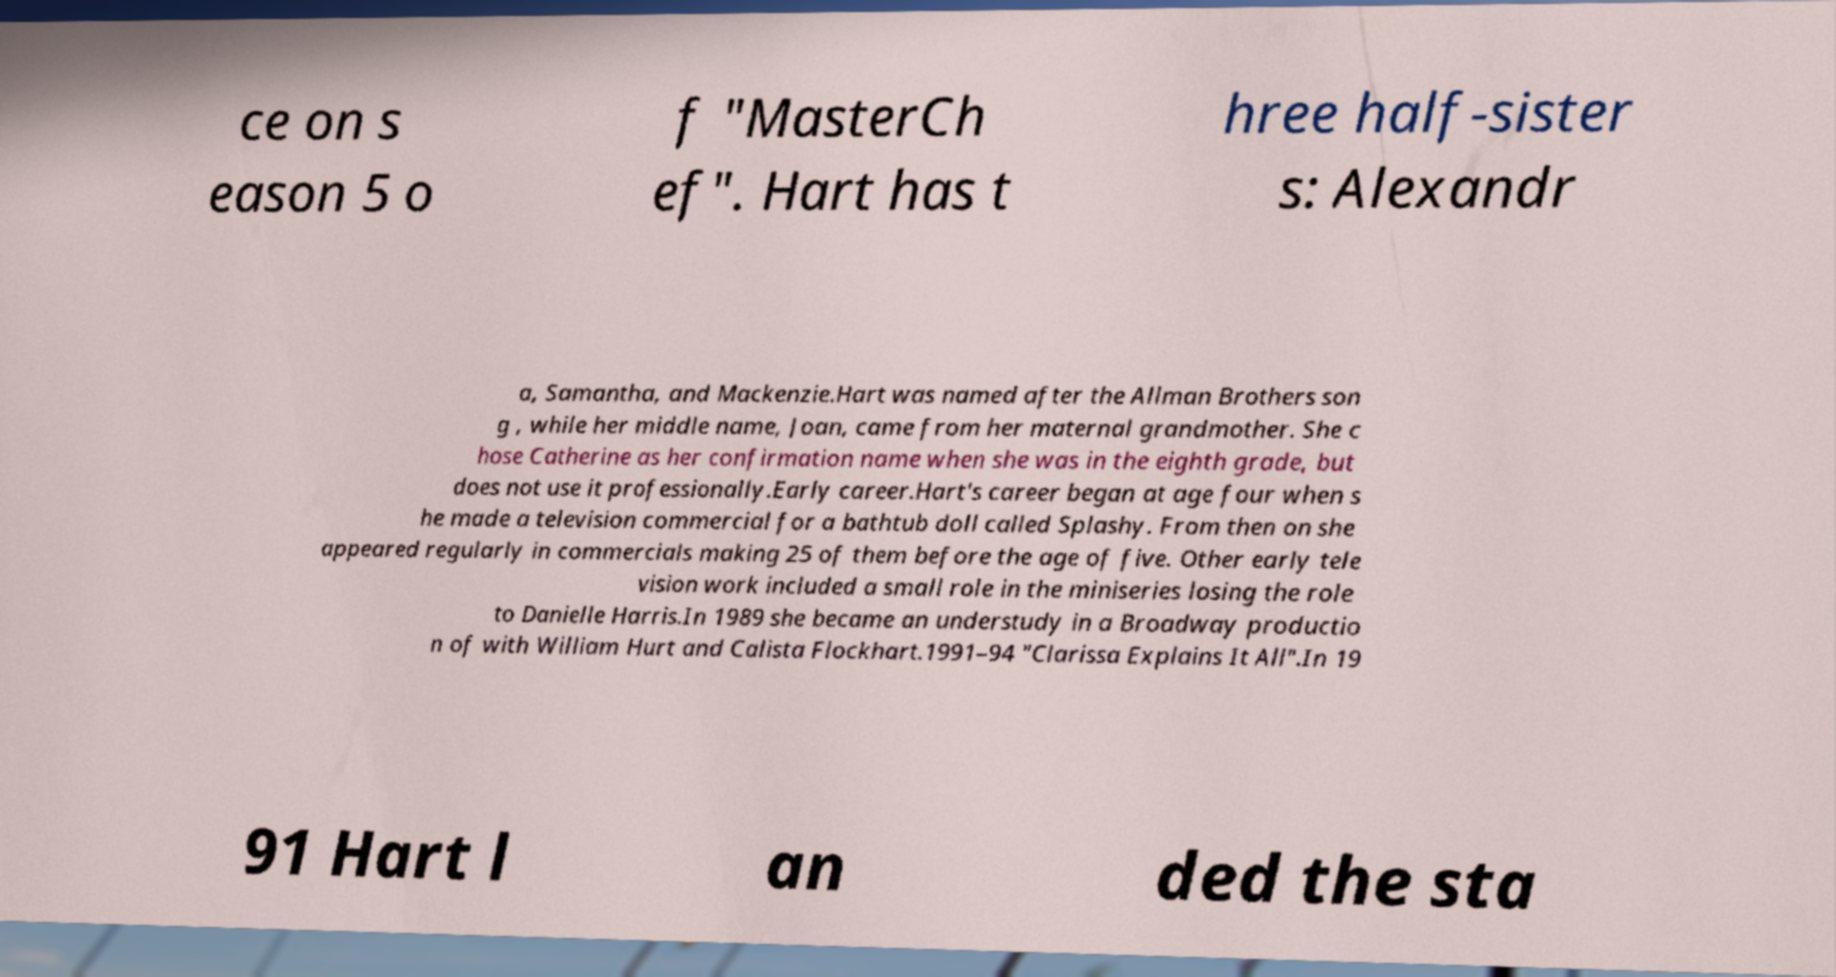Please read and relay the text visible in this image. What does it say? ce on s eason 5 o f "MasterCh ef". Hart has t hree half-sister s: Alexandr a, Samantha, and Mackenzie.Hart was named after the Allman Brothers son g , while her middle name, Joan, came from her maternal grandmother. She c hose Catherine as her confirmation name when she was in the eighth grade, but does not use it professionally.Early career.Hart's career began at age four when s he made a television commercial for a bathtub doll called Splashy. From then on she appeared regularly in commercials making 25 of them before the age of five. Other early tele vision work included a small role in the miniseries losing the role to Danielle Harris.In 1989 she became an understudy in a Broadway productio n of with William Hurt and Calista Flockhart.1991–94 "Clarissa Explains It All".In 19 91 Hart l an ded the sta 